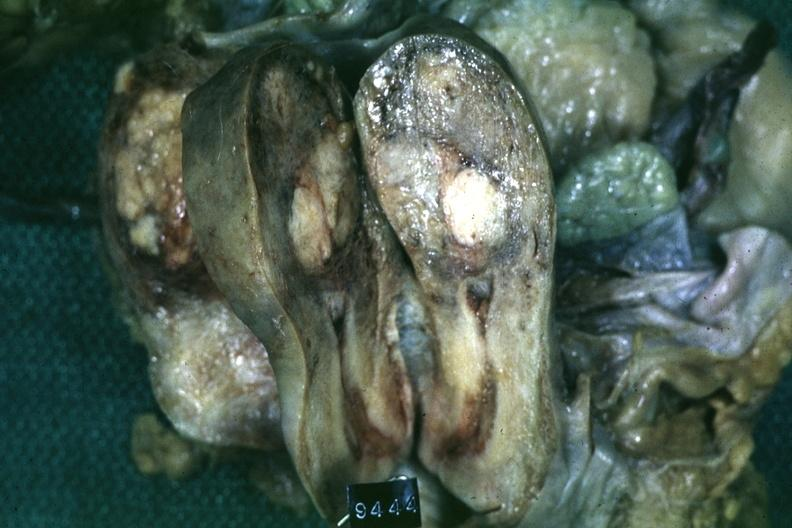s leiomyoma present?
Answer the question using a single word or phrase. Yes 